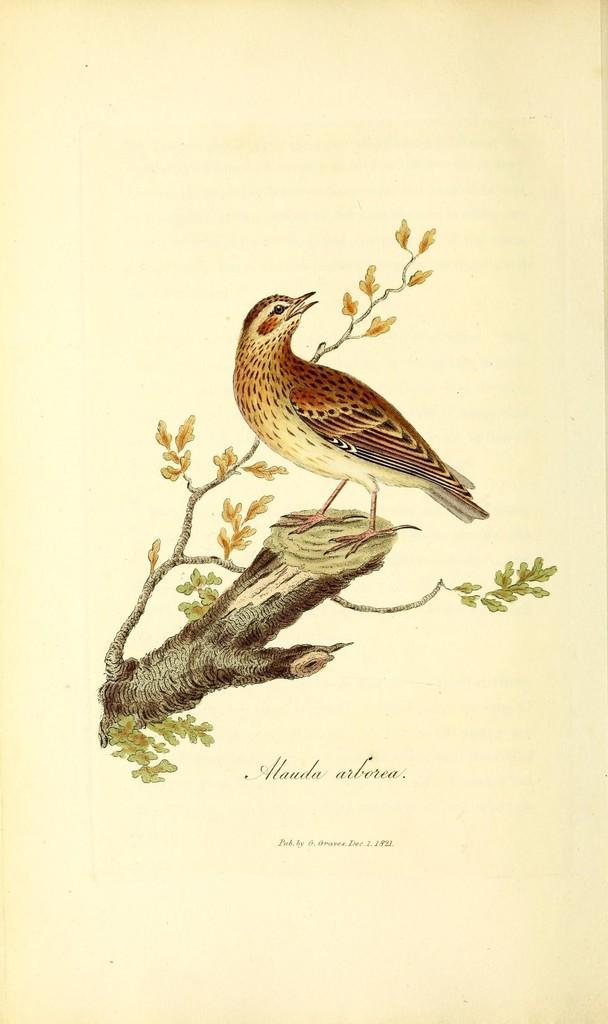Could you give a brief overview of what you see in this image? The picture is looking like a paper in a book. in the center of the picture we can see stems, leaves and a branch. On the stem we can see a bird. At the bottom there is text. 